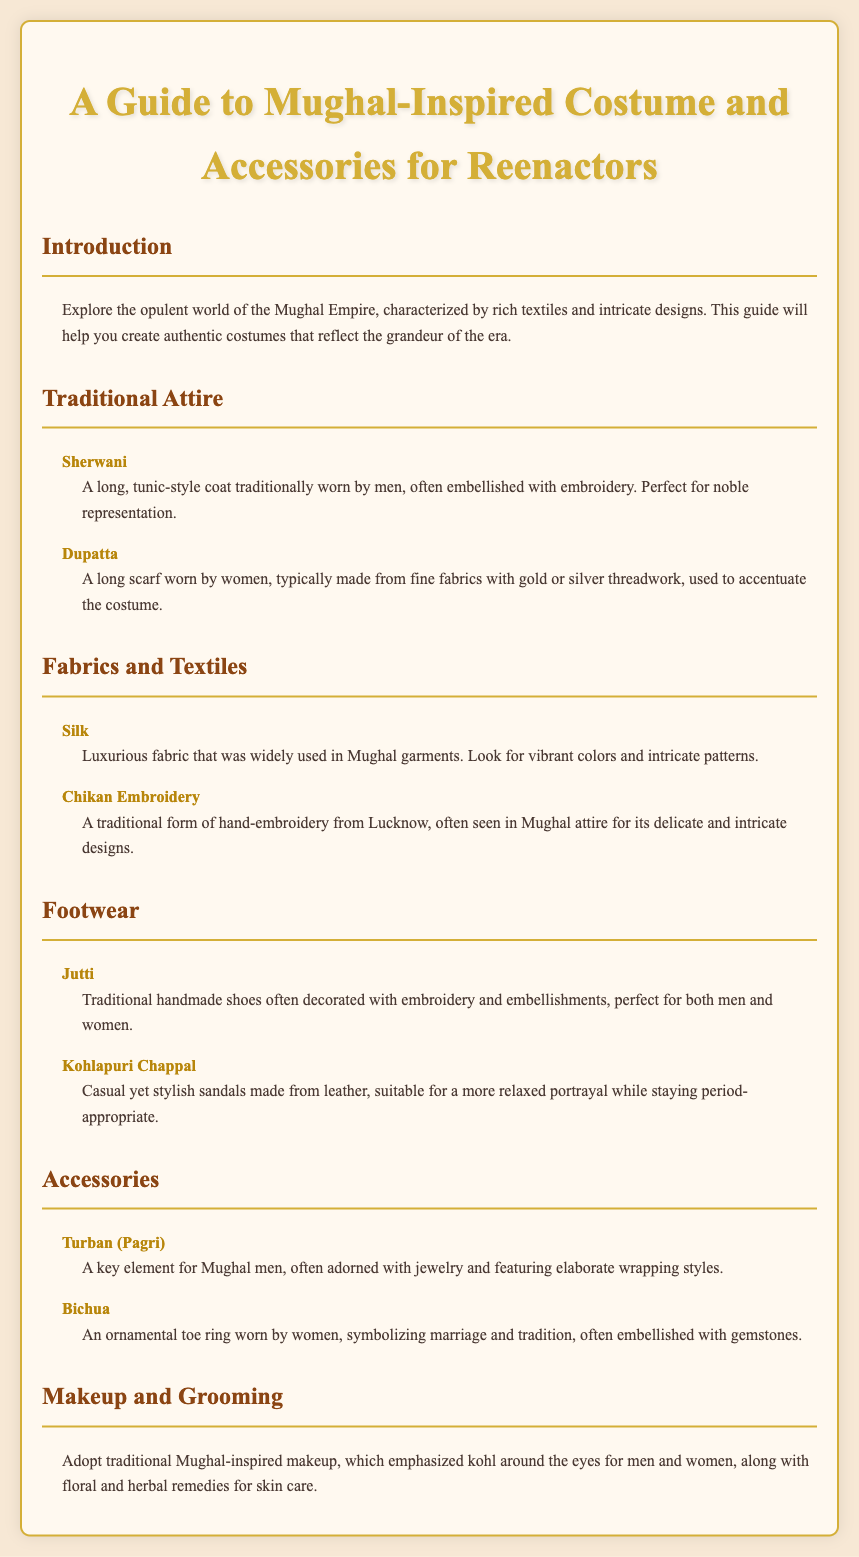What is the title of the document? The title of the document is stated in the header section, describing the content specifically related to Mughal-inspired costumes for reenactors.
Answer: A Guide to Mughal-Inspired Costume and Accessories for Reenactors What is a Sherwani? The document describes a Sherwani as a long, tunic-style coat traditionally worn by men, embellished with embroidery.
Answer: A long, tunic-style coat What type of embroidery is mentioned in the document? The document lists Chikan Embroidery as a traditional form of hand-embroidery often seen in Mughal attire.
Answer: Chikan Embroidery What footwear is described as casual yet stylish? The document specifically mentions Kohlapuri Chappal as a casual yet stylish option suitable for a relaxed portrayal.
Answer: Kohlapuri Chappal What makeup is emphasized for Mughal-inspired looks? The makeup section highlights the use of kohl around the eyes for both men and women as a significant part of traditional Mughal-inspired makeup.
Answer: Kohl What accessory is a key element for Mughal men? The document identifies the Turban (Pagri) as a key element for Mughal men, often adorned with jewelry.
Answer: Turban (Pagri) How many traditional attire items are listed in the menu? The Traditional Attire section contains two listed items: Sherwani and Dupatta.
Answer: 2 What is the primary focus of the document? The document's primary focus is on providing guidance for creating authentic Mughal-inspired costumes and accessories for reenactors.
Answer: Authentic costumes 